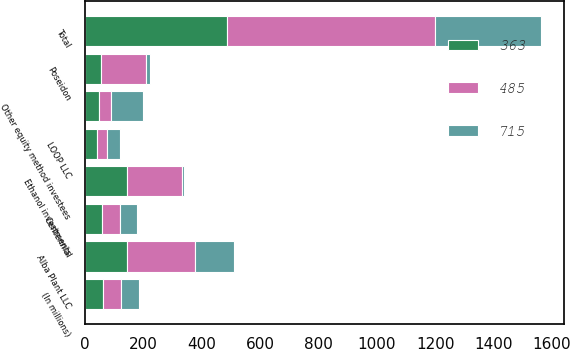Convert chart. <chart><loc_0><loc_0><loc_500><loc_500><stacked_bar_chart><ecel><fcel>(In millions)<fcel>Alba Plant LLC<fcel>Ethanol investments<fcel>Poseidon<fcel>Centennial<fcel>LOOP LLC<fcel>Other equity method investees<fcel>Total<nl><fcel>363<fcel>61<fcel>143<fcel>143<fcel>53<fcel>58<fcel>40<fcel>48<fcel>485<nl><fcel>485<fcel>61<fcel>235<fcel>188<fcel>154<fcel>61<fcel>35<fcel>42<fcel>715<nl><fcel>715<fcel>61<fcel>131<fcel>9<fcel>16<fcel>57<fcel>43<fcel>107<fcel>363<nl></chart> 